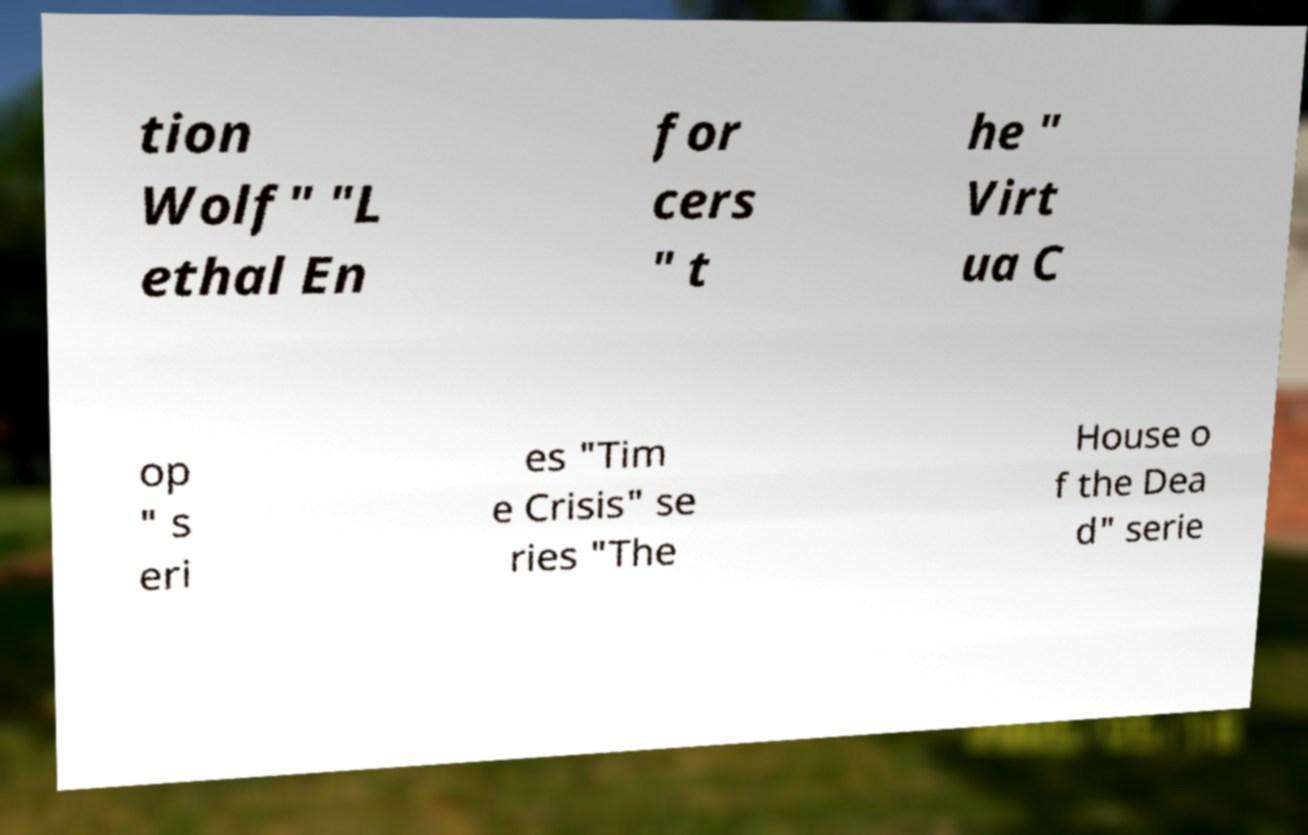What messages or text are displayed in this image? I need them in a readable, typed format. tion Wolf" "L ethal En for cers " t he " Virt ua C op " s eri es "Tim e Crisis" se ries "The House o f the Dea d" serie 